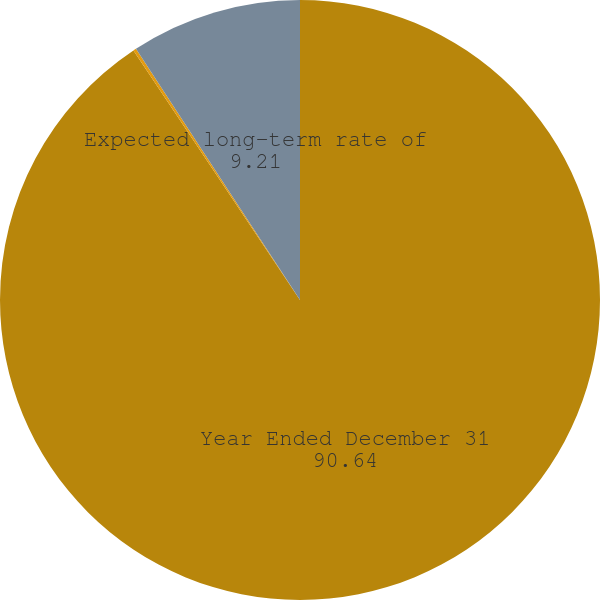<chart> <loc_0><loc_0><loc_500><loc_500><pie_chart><fcel>Year Ended December 31<fcel>Discount rate<fcel>Expected long-term rate of<nl><fcel>90.64%<fcel>0.16%<fcel>9.21%<nl></chart> 